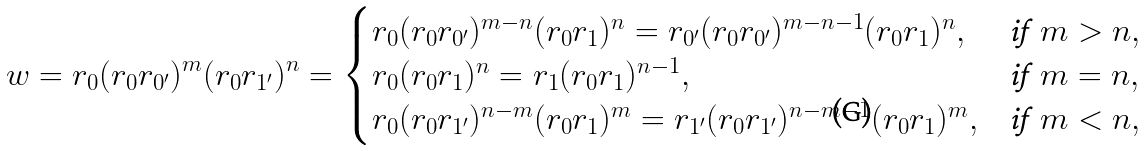<formula> <loc_0><loc_0><loc_500><loc_500>w = r _ { 0 } ( r _ { 0 } r _ { 0 ^ { \prime } } ) ^ { m } ( r _ { 0 } r _ { 1 ^ { \prime } } ) ^ { n } = \begin{cases} r _ { 0 } ( r _ { 0 } r _ { 0 ^ { \prime } } ) ^ { m - n } ( r _ { 0 } r _ { 1 } ) ^ { n } = r _ { 0 ^ { \prime } } ( r _ { 0 } r _ { 0 ^ { \prime } } ) ^ { m - n - 1 } ( r _ { 0 } r _ { 1 } ) ^ { n } , & \text {if} \, \ m > n , \\ r _ { 0 } ( r _ { 0 } r _ { 1 } ) ^ { n } = r _ { 1 } ( r _ { 0 } r _ { 1 } ) ^ { n - 1 } , & \text {if} \, \ m = n , \\ r _ { 0 } ( r _ { 0 } r _ { 1 ^ { \prime } } ) ^ { n - m } ( r _ { 0 } r _ { 1 } ) ^ { m } = r _ { 1 ^ { \prime } } ( r _ { 0 } r _ { 1 ^ { \prime } } ) ^ { n - m - 1 } ( r _ { 0 } r _ { 1 } ) ^ { m } , & \text {if} \, \ m < n , \end{cases}</formula> 